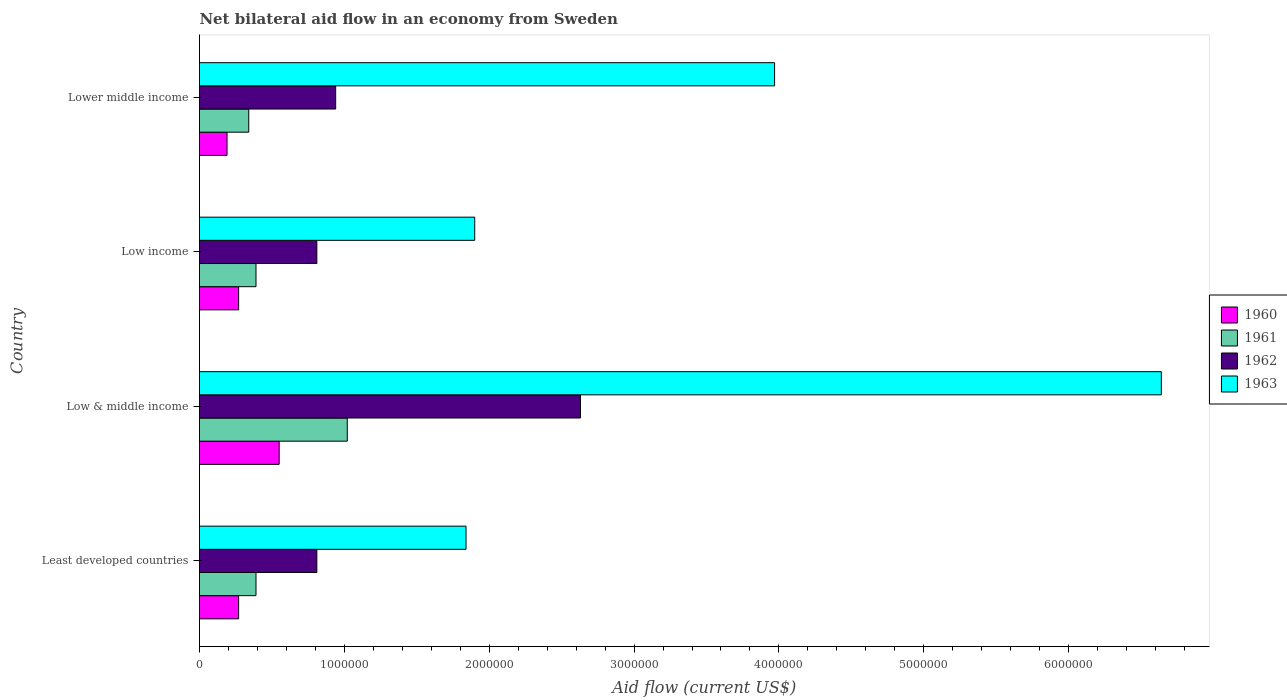Are the number of bars per tick equal to the number of legend labels?
Provide a succinct answer. Yes. Are the number of bars on each tick of the Y-axis equal?
Give a very brief answer. Yes. What is the label of the 1st group of bars from the top?
Provide a succinct answer. Lower middle income. In how many cases, is the number of bars for a given country not equal to the number of legend labels?
Your response must be concise. 0. What is the net bilateral aid flow in 1963 in Least developed countries?
Keep it short and to the point. 1.84e+06. Across all countries, what is the maximum net bilateral aid flow in 1963?
Keep it short and to the point. 6.64e+06. In which country was the net bilateral aid flow in 1961 minimum?
Provide a short and direct response. Lower middle income. What is the total net bilateral aid flow in 1960 in the graph?
Provide a short and direct response. 1.28e+06. What is the difference between the net bilateral aid flow in 1961 in Least developed countries and that in Low & middle income?
Keep it short and to the point. -6.30e+05. What is the difference between the net bilateral aid flow in 1961 in Lower middle income and the net bilateral aid flow in 1963 in Low & middle income?
Your answer should be compact. -6.30e+06. What is the average net bilateral aid flow in 1962 per country?
Make the answer very short. 1.30e+06. What is the difference between the net bilateral aid flow in 1960 and net bilateral aid flow in 1962 in Low & middle income?
Keep it short and to the point. -2.08e+06. What is the ratio of the net bilateral aid flow in 1960 in Low income to that in Lower middle income?
Offer a very short reply. 1.42. What is the difference between the highest and the second highest net bilateral aid flow in 1961?
Your answer should be compact. 6.30e+05. What is the difference between the highest and the lowest net bilateral aid flow in 1961?
Offer a very short reply. 6.80e+05. Is the sum of the net bilateral aid flow in 1960 in Least developed countries and Lower middle income greater than the maximum net bilateral aid flow in 1962 across all countries?
Offer a very short reply. No. What does the 1st bar from the top in Least developed countries represents?
Ensure brevity in your answer.  1963. Is it the case that in every country, the sum of the net bilateral aid flow in 1962 and net bilateral aid flow in 1963 is greater than the net bilateral aid flow in 1960?
Provide a short and direct response. Yes. Are all the bars in the graph horizontal?
Give a very brief answer. Yes. Does the graph contain any zero values?
Your answer should be very brief. No. Where does the legend appear in the graph?
Offer a terse response. Center right. How many legend labels are there?
Your answer should be very brief. 4. How are the legend labels stacked?
Your answer should be compact. Vertical. What is the title of the graph?
Your answer should be compact. Net bilateral aid flow in an economy from Sweden. Does "2011" appear as one of the legend labels in the graph?
Provide a short and direct response. No. What is the label or title of the X-axis?
Provide a succinct answer. Aid flow (current US$). What is the label or title of the Y-axis?
Offer a very short reply. Country. What is the Aid flow (current US$) of 1960 in Least developed countries?
Offer a very short reply. 2.70e+05. What is the Aid flow (current US$) in 1962 in Least developed countries?
Provide a succinct answer. 8.10e+05. What is the Aid flow (current US$) of 1963 in Least developed countries?
Provide a succinct answer. 1.84e+06. What is the Aid flow (current US$) of 1961 in Low & middle income?
Offer a terse response. 1.02e+06. What is the Aid flow (current US$) in 1962 in Low & middle income?
Give a very brief answer. 2.63e+06. What is the Aid flow (current US$) of 1963 in Low & middle income?
Your answer should be compact. 6.64e+06. What is the Aid flow (current US$) in 1961 in Low income?
Your answer should be very brief. 3.90e+05. What is the Aid flow (current US$) of 1962 in Low income?
Keep it short and to the point. 8.10e+05. What is the Aid flow (current US$) of 1963 in Low income?
Make the answer very short. 1.90e+06. What is the Aid flow (current US$) in 1961 in Lower middle income?
Ensure brevity in your answer.  3.40e+05. What is the Aid flow (current US$) in 1962 in Lower middle income?
Provide a short and direct response. 9.40e+05. What is the Aid flow (current US$) in 1963 in Lower middle income?
Provide a short and direct response. 3.97e+06. Across all countries, what is the maximum Aid flow (current US$) of 1961?
Provide a short and direct response. 1.02e+06. Across all countries, what is the maximum Aid flow (current US$) in 1962?
Provide a short and direct response. 2.63e+06. Across all countries, what is the maximum Aid flow (current US$) of 1963?
Give a very brief answer. 6.64e+06. Across all countries, what is the minimum Aid flow (current US$) of 1962?
Your answer should be very brief. 8.10e+05. Across all countries, what is the minimum Aid flow (current US$) of 1963?
Give a very brief answer. 1.84e+06. What is the total Aid flow (current US$) in 1960 in the graph?
Give a very brief answer. 1.28e+06. What is the total Aid flow (current US$) in 1961 in the graph?
Offer a terse response. 2.14e+06. What is the total Aid flow (current US$) in 1962 in the graph?
Offer a terse response. 5.19e+06. What is the total Aid flow (current US$) of 1963 in the graph?
Provide a short and direct response. 1.44e+07. What is the difference between the Aid flow (current US$) of 1960 in Least developed countries and that in Low & middle income?
Give a very brief answer. -2.80e+05. What is the difference between the Aid flow (current US$) of 1961 in Least developed countries and that in Low & middle income?
Offer a terse response. -6.30e+05. What is the difference between the Aid flow (current US$) in 1962 in Least developed countries and that in Low & middle income?
Offer a terse response. -1.82e+06. What is the difference between the Aid flow (current US$) of 1963 in Least developed countries and that in Low & middle income?
Your answer should be very brief. -4.80e+06. What is the difference between the Aid flow (current US$) in 1961 in Least developed countries and that in Low income?
Your answer should be compact. 0. What is the difference between the Aid flow (current US$) in 1961 in Least developed countries and that in Lower middle income?
Provide a short and direct response. 5.00e+04. What is the difference between the Aid flow (current US$) of 1962 in Least developed countries and that in Lower middle income?
Offer a very short reply. -1.30e+05. What is the difference between the Aid flow (current US$) of 1963 in Least developed countries and that in Lower middle income?
Provide a succinct answer. -2.13e+06. What is the difference between the Aid flow (current US$) in 1960 in Low & middle income and that in Low income?
Offer a terse response. 2.80e+05. What is the difference between the Aid flow (current US$) of 1961 in Low & middle income and that in Low income?
Keep it short and to the point. 6.30e+05. What is the difference between the Aid flow (current US$) of 1962 in Low & middle income and that in Low income?
Offer a very short reply. 1.82e+06. What is the difference between the Aid flow (current US$) of 1963 in Low & middle income and that in Low income?
Keep it short and to the point. 4.74e+06. What is the difference between the Aid flow (current US$) in 1960 in Low & middle income and that in Lower middle income?
Your response must be concise. 3.60e+05. What is the difference between the Aid flow (current US$) in 1961 in Low & middle income and that in Lower middle income?
Your answer should be compact. 6.80e+05. What is the difference between the Aid flow (current US$) in 1962 in Low & middle income and that in Lower middle income?
Provide a short and direct response. 1.69e+06. What is the difference between the Aid flow (current US$) of 1963 in Low & middle income and that in Lower middle income?
Provide a short and direct response. 2.67e+06. What is the difference between the Aid flow (current US$) in 1961 in Low income and that in Lower middle income?
Your response must be concise. 5.00e+04. What is the difference between the Aid flow (current US$) in 1963 in Low income and that in Lower middle income?
Your answer should be compact. -2.07e+06. What is the difference between the Aid flow (current US$) in 1960 in Least developed countries and the Aid flow (current US$) in 1961 in Low & middle income?
Your response must be concise. -7.50e+05. What is the difference between the Aid flow (current US$) of 1960 in Least developed countries and the Aid flow (current US$) of 1962 in Low & middle income?
Keep it short and to the point. -2.36e+06. What is the difference between the Aid flow (current US$) in 1960 in Least developed countries and the Aid flow (current US$) in 1963 in Low & middle income?
Provide a succinct answer. -6.37e+06. What is the difference between the Aid flow (current US$) of 1961 in Least developed countries and the Aid flow (current US$) of 1962 in Low & middle income?
Provide a succinct answer. -2.24e+06. What is the difference between the Aid flow (current US$) of 1961 in Least developed countries and the Aid flow (current US$) of 1963 in Low & middle income?
Your response must be concise. -6.25e+06. What is the difference between the Aid flow (current US$) of 1962 in Least developed countries and the Aid flow (current US$) of 1963 in Low & middle income?
Offer a terse response. -5.83e+06. What is the difference between the Aid flow (current US$) in 1960 in Least developed countries and the Aid flow (current US$) in 1961 in Low income?
Give a very brief answer. -1.20e+05. What is the difference between the Aid flow (current US$) in 1960 in Least developed countries and the Aid flow (current US$) in 1962 in Low income?
Give a very brief answer. -5.40e+05. What is the difference between the Aid flow (current US$) of 1960 in Least developed countries and the Aid flow (current US$) of 1963 in Low income?
Keep it short and to the point. -1.63e+06. What is the difference between the Aid flow (current US$) in 1961 in Least developed countries and the Aid flow (current US$) in 1962 in Low income?
Offer a terse response. -4.20e+05. What is the difference between the Aid flow (current US$) of 1961 in Least developed countries and the Aid flow (current US$) of 1963 in Low income?
Keep it short and to the point. -1.51e+06. What is the difference between the Aid flow (current US$) of 1962 in Least developed countries and the Aid flow (current US$) of 1963 in Low income?
Make the answer very short. -1.09e+06. What is the difference between the Aid flow (current US$) in 1960 in Least developed countries and the Aid flow (current US$) in 1961 in Lower middle income?
Your response must be concise. -7.00e+04. What is the difference between the Aid flow (current US$) of 1960 in Least developed countries and the Aid flow (current US$) of 1962 in Lower middle income?
Your answer should be compact. -6.70e+05. What is the difference between the Aid flow (current US$) of 1960 in Least developed countries and the Aid flow (current US$) of 1963 in Lower middle income?
Offer a terse response. -3.70e+06. What is the difference between the Aid flow (current US$) of 1961 in Least developed countries and the Aid flow (current US$) of 1962 in Lower middle income?
Offer a very short reply. -5.50e+05. What is the difference between the Aid flow (current US$) of 1961 in Least developed countries and the Aid flow (current US$) of 1963 in Lower middle income?
Your answer should be compact. -3.58e+06. What is the difference between the Aid flow (current US$) of 1962 in Least developed countries and the Aid flow (current US$) of 1963 in Lower middle income?
Keep it short and to the point. -3.16e+06. What is the difference between the Aid flow (current US$) of 1960 in Low & middle income and the Aid flow (current US$) of 1962 in Low income?
Keep it short and to the point. -2.60e+05. What is the difference between the Aid flow (current US$) of 1960 in Low & middle income and the Aid flow (current US$) of 1963 in Low income?
Provide a short and direct response. -1.35e+06. What is the difference between the Aid flow (current US$) of 1961 in Low & middle income and the Aid flow (current US$) of 1963 in Low income?
Give a very brief answer. -8.80e+05. What is the difference between the Aid flow (current US$) of 1962 in Low & middle income and the Aid flow (current US$) of 1963 in Low income?
Provide a short and direct response. 7.30e+05. What is the difference between the Aid flow (current US$) of 1960 in Low & middle income and the Aid flow (current US$) of 1961 in Lower middle income?
Provide a short and direct response. 2.10e+05. What is the difference between the Aid flow (current US$) in 1960 in Low & middle income and the Aid flow (current US$) in 1962 in Lower middle income?
Keep it short and to the point. -3.90e+05. What is the difference between the Aid flow (current US$) of 1960 in Low & middle income and the Aid flow (current US$) of 1963 in Lower middle income?
Keep it short and to the point. -3.42e+06. What is the difference between the Aid flow (current US$) in 1961 in Low & middle income and the Aid flow (current US$) in 1963 in Lower middle income?
Give a very brief answer. -2.95e+06. What is the difference between the Aid flow (current US$) of 1962 in Low & middle income and the Aid flow (current US$) of 1963 in Lower middle income?
Ensure brevity in your answer.  -1.34e+06. What is the difference between the Aid flow (current US$) in 1960 in Low income and the Aid flow (current US$) in 1961 in Lower middle income?
Your answer should be compact. -7.00e+04. What is the difference between the Aid flow (current US$) in 1960 in Low income and the Aid flow (current US$) in 1962 in Lower middle income?
Give a very brief answer. -6.70e+05. What is the difference between the Aid flow (current US$) in 1960 in Low income and the Aid flow (current US$) in 1963 in Lower middle income?
Provide a short and direct response. -3.70e+06. What is the difference between the Aid flow (current US$) in 1961 in Low income and the Aid flow (current US$) in 1962 in Lower middle income?
Make the answer very short. -5.50e+05. What is the difference between the Aid flow (current US$) of 1961 in Low income and the Aid flow (current US$) of 1963 in Lower middle income?
Offer a terse response. -3.58e+06. What is the difference between the Aid flow (current US$) in 1962 in Low income and the Aid flow (current US$) in 1963 in Lower middle income?
Your answer should be very brief. -3.16e+06. What is the average Aid flow (current US$) of 1961 per country?
Give a very brief answer. 5.35e+05. What is the average Aid flow (current US$) in 1962 per country?
Offer a terse response. 1.30e+06. What is the average Aid flow (current US$) in 1963 per country?
Provide a short and direct response. 3.59e+06. What is the difference between the Aid flow (current US$) in 1960 and Aid flow (current US$) in 1961 in Least developed countries?
Offer a very short reply. -1.20e+05. What is the difference between the Aid flow (current US$) in 1960 and Aid flow (current US$) in 1962 in Least developed countries?
Offer a very short reply. -5.40e+05. What is the difference between the Aid flow (current US$) of 1960 and Aid flow (current US$) of 1963 in Least developed countries?
Keep it short and to the point. -1.57e+06. What is the difference between the Aid flow (current US$) of 1961 and Aid flow (current US$) of 1962 in Least developed countries?
Provide a succinct answer. -4.20e+05. What is the difference between the Aid flow (current US$) of 1961 and Aid flow (current US$) of 1963 in Least developed countries?
Your answer should be very brief. -1.45e+06. What is the difference between the Aid flow (current US$) in 1962 and Aid flow (current US$) in 1963 in Least developed countries?
Your response must be concise. -1.03e+06. What is the difference between the Aid flow (current US$) of 1960 and Aid flow (current US$) of 1961 in Low & middle income?
Ensure brevity in your answer.  -4.70e+05. What is the difference between the Aid flow (current US$) of 1960 and Aid flow (current US$) of 1962 in Low & middle income?
Offer a terse response. -2.08e+06. What is the difference between the Aid flow (current US$) in 1960 and Aid flow (current US$) in 1963 in Low & middle income?
Make the answer very short. -6.09e+06. What is the difference between the Aid flow (current US$) of 1961 and Aid flow (current US$) of 1962 in Low & middle income?
Provide a succinct answer. -1.61e+06. What is the difference between the Aid flow (current US$) in 1961 and Aid flow (current US$) in 1963 in Low & middle income?
Provide a short and direct response. -5.62e+06. What is the difference between the Aid flow (current US$) of 1962 and Aid flow (current US$) of 1963 in Low & middle income?
Keep it short and to the point. -4.01e+06. What is the difference between the Aid flow (current US$) of 1960 and Aid flow (current US$) of 1962 in Low income?
Keep it short and to the point. -5.40e+05. What is the difference between the Aid flow (current US$) in 1960 and Aid flow (current US$) in 1963 in Low income?
Offer a terse response. -1.63e+06. What is the difference between the Aid flow (current US$) in 1961 and Aid flow (current US$) in 1962 in Low income?
Make the answer very short. -4.20e+05. What is the difference between the Aid flow (current US$) in 1961 and Aid flow (current US$) in 1963 in Low income?
Your answer should be compact. -1.51e+06. What is the difference between the Aid flow (current US$) of 1962 and Aid flow (current US$) of 1963 in Low income?
Provide a succinct answer. -1.09e+06. What is the difference between the Aid flow (current US$) in 1960 and Aid flow (current US$) in 1961 in Lower middle income?
Your answer should be compact. -1.50e+05. What is the difference between the Aid flow (current US$) of 1960 and Aid flow (current US$) of 1962 in Lower middle income?
Offer a terse response. -7.50e+05. What is the difference between the Aid flow (current US$) in 1960 and Aid flow (current US$) in 1963 in Lower middle income?
Offer a terse response. -3.78e+06. What is the difference between the Aid flow (current US$) in 1961 and Aid flow (current US$) in 1962 in Lower middle income?
Ensure brevity in your answer.  -6.00e+05. What is the difference between the Aid flow (current US$) of 1961 and Aid flow (current US$) of 1963 in Lower middle income?
Your answer should be very brief. -3.63e+06. What is the difference between the Aid flow (current US$) of 1962 and Aid flow (current US$) of 1963 in Lower middle income?
Offer a very short reply. -3.03e+06. What is the ratio of the Aid flow (current US$) in 1960 in Least developed countries to that in Low & middle income?
Provide a short and direct response. 0.49. What is the ratio of the Aid flow (current US$) in 1961 in Least developed countries to that in Low & middle income?
Offer a terse response. 0.38. What is the ratio of the Aid flow (current US$) of 1962 in Least developed countries to that in Low & middle income?
Ensure brevity in your answer.  0.31. What is the ratio of the Aid flow (current US$) in 1963 in Least developed countries to that in Low & middle income?
Make the answer very short. 0.28. What is the ratio of the Aid flow (current US$) of 1961 in Least developed countries to that in Low income?
Offer a terse response. 1. What is the ratio of the Aid flow (current US$) of 1963 in Least developed countries to that in Low income?
Offer a terse response. 0.97. What is the ratio of the Aid flow (current US$) of 1960 in Least developed countries to that in Lower middle income?
Your answer should be very brief. 1.42. What is the ratio of the Aid flow (current US$) in 1961 in Least developed countries to that in Lower middle income?
Offer a terse response. 1.15. What is the ratio of the Aid flow (current US$) in 1962 in Least developed countries to that in Lower middle income?
Ensure brevity in your answer.  0.86. What is the ratio of the Aid flow (current US$) in 1963 in Least developed countries to that in Lower middle income?
Give a very brief answer. 0.46. What is the ratio of the Aid flow (current US$) in 1960 in Low & middle income to that in Low income?
Offer a terse response. 2.04. What is the ratio of the Aid flow (current US$) in 1961 in Low & middle income to that in Low income?
Provide a short and direct response. 2.62. What is the ratio of the Aid flow (current US$) in 1962 in Low & middle income to that in Low income?
Keep it short and to the point. 3.25. What is the ratio of the Aid flow (current US$) of 1963 in Low & middle income to that in Low income?
Make the answer very short. 3.49. What is the ratio of the Aid flow (current US$) of 1960 in Low & middle income to that in Lower middle income?
Ensure brevity in your answer.  2.89. What is the ratio of the Aid flow (current US$) in 1962 in Low & middle income to that in Lower middle income?
Keep it short and to the point. 2.8. What is the ratio of the Aid flow (current US$) of 1963 in Low & middle income to that in Lower middle income?
Give a very brief answer. 1.67. What is the ratio of the Aid flow (current US$) in 1960 in Low income to that in Lower middle income?
Keep it short and to the point. 1.42. What is the ratio of the Aid flow (current US$) in 1961 in Low income to that in Lower middle income?
Provide a succinct answer. 1.15. What is the ratio of the Aid flow (current US$) of 1962 in Low income to that in Lower middle income?
Make the answer very short. 0.86. What is the ratio of the Aid flow (current US$) in 1963 in Low income to that in Lower middle income?
Your answer should be compact. 0.48. What is the difference between the highest and the second highest Aid flow (current US$) in 1960?
Your answer should be compact. 2.80e+05. What is the difference between the highest and the second highest Aid flow (current US$) of 1961?
Keep it short and to the point. 6.30e+05. What is the difference between the highest and the second highest Aid flow (current US$) of 1962?
Ensure brevity in your answer.  1.69e+06. What is the difference between the highest and the second highest Aid flow (current US$) of 1963?
Give a very brief answer. 2.67e+06. What is the difference between the highest and the lowest Aid flow (current US$) of 1960?
Offer a terse response. 3.60e+05. What is the difference between the highest and the lowest Aid flow (current US$) in 1961?
Your answer should be very brief. 6.80e+05. What is the difference between the highest and the lowest Aid flow (current US$) in 1962?
Provide a short and direct response. 1.82e+06. What is the difference between the highest and the lowest Aid flow (current US$) of 1963?
Offer a very short reply. 4.80e+06. 